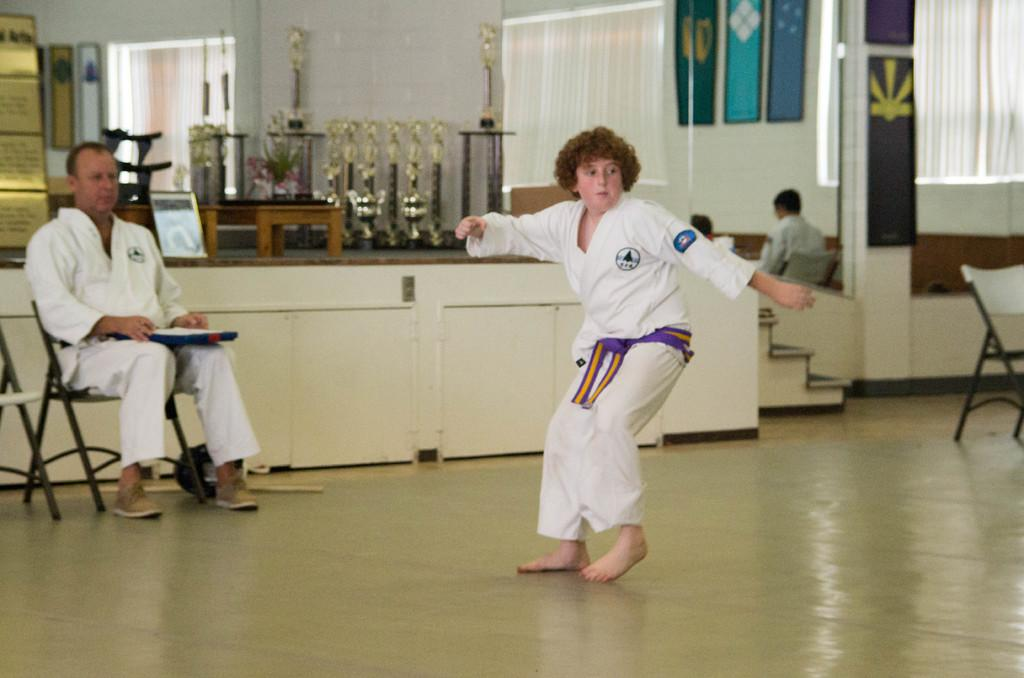What is the guy in the image wearing? The guy in the image is wearing a karate uniform. Who else is present in the image? There is a man looking at the guy in the karate uniform. What might be the context of the image? The situation appears to be a competition. What fact can be stated about the stop sign in the image? There is no stop sign present in the image. 